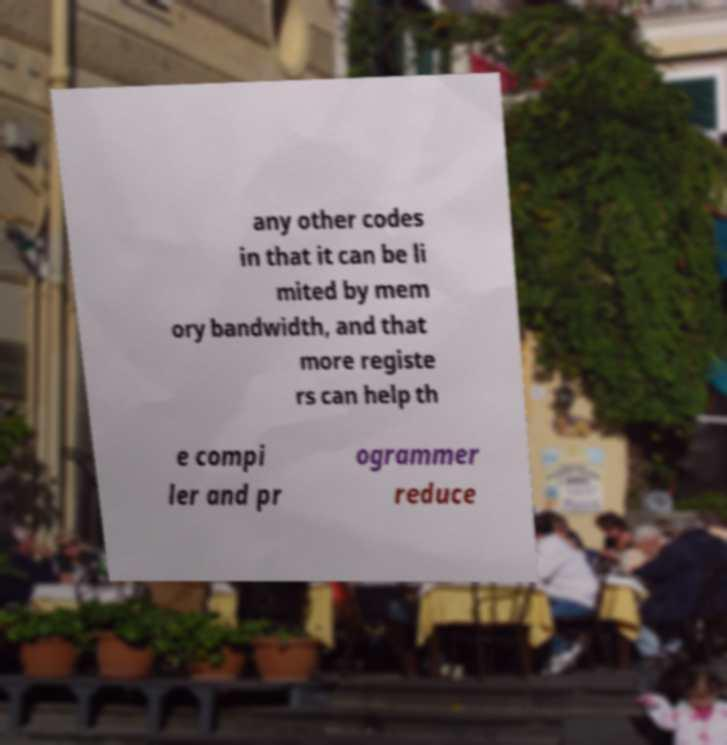For documentation purposes, I need the text within this image transcribed. Could you provide that? any other codes in that it can be li mited by mem ory bandwidth, and that more registe rs can help th e compi ler and pr ogrammer reduce 